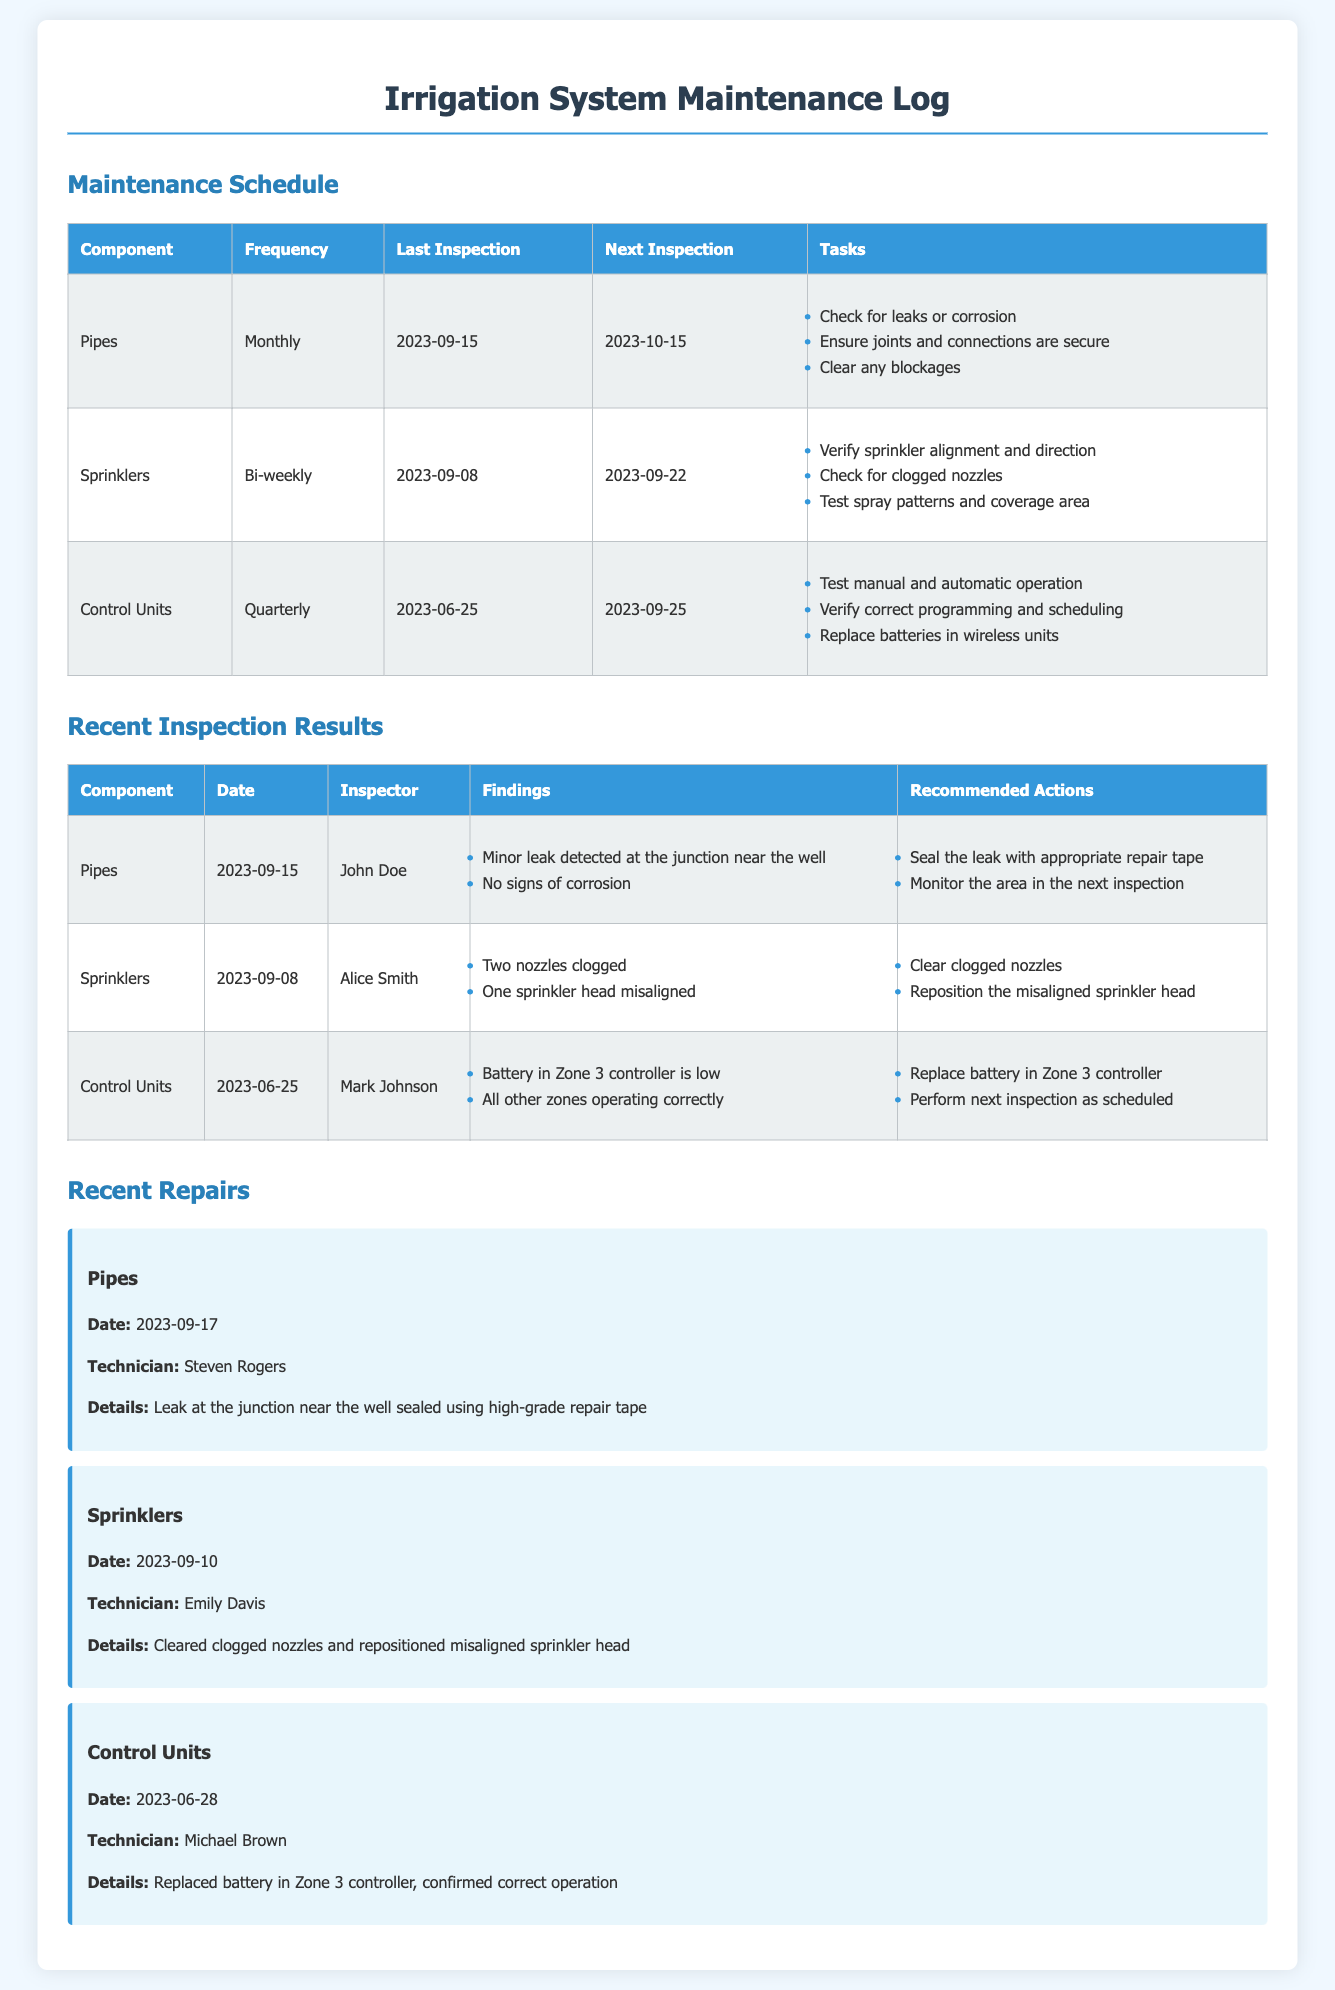What is the frequency of sprinkler maintenance? The maintenance schedule indicates that sprinklers are checked bi-weekly.
Answer: Bi-weekly When was the last inspection of control units? The last inspection date for control units is noted as June 25, 2023.
Answer: 2023-06-25 Who inspected the pipes during the last inspection? The inspector for the pipes on September 15, 2023, is mentioned as John Doe.
Answer: John Doe What was one of the findings for the sprinklers during the recent inspection? One of the findings was that two nozzles were clogged.
Answer: Two nozzles clogged What action was recommended for the minor leak detected in the pipes? The recommendation included sealing the leak with appropriate repair tape.
Answer: Seal the leak with appropriate repair tape What was replaced during the repair of the control units? The battery in Zone 3 controller was replaced.
Answer: Battery in Zone 3 controller When is the next scheduled inspection for the pipes? The next inspection for pipes is scheduled for October 15, 2023.
Answer: 2023-10-15 Who performed the recent repair on the sprinklers? The technician who performed the repair on the sprinklers is Emily Davis.
Answer: Emily Davis What detail is noted about the recent repair of the pipes? The repair of the pipes involved sealing a leak at the junction near the well.
Answer: Sealed a leak at the junction near the well 